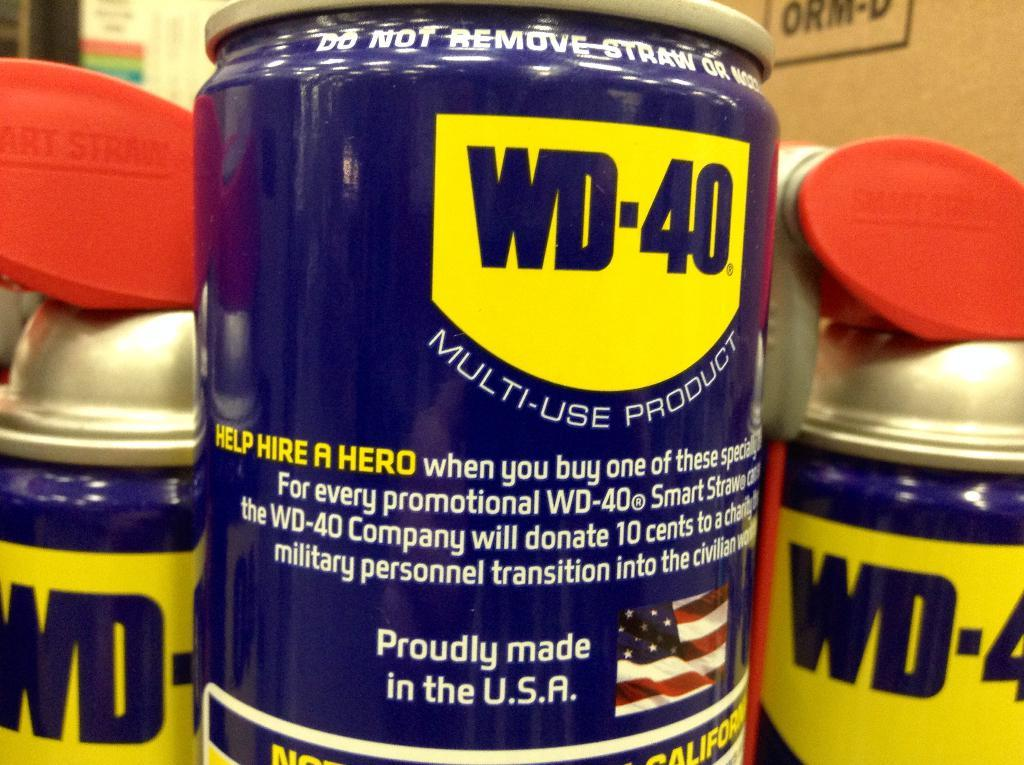<image>
Create a compact narrative representing the image presented. # cans of WD-40 are shown up close 